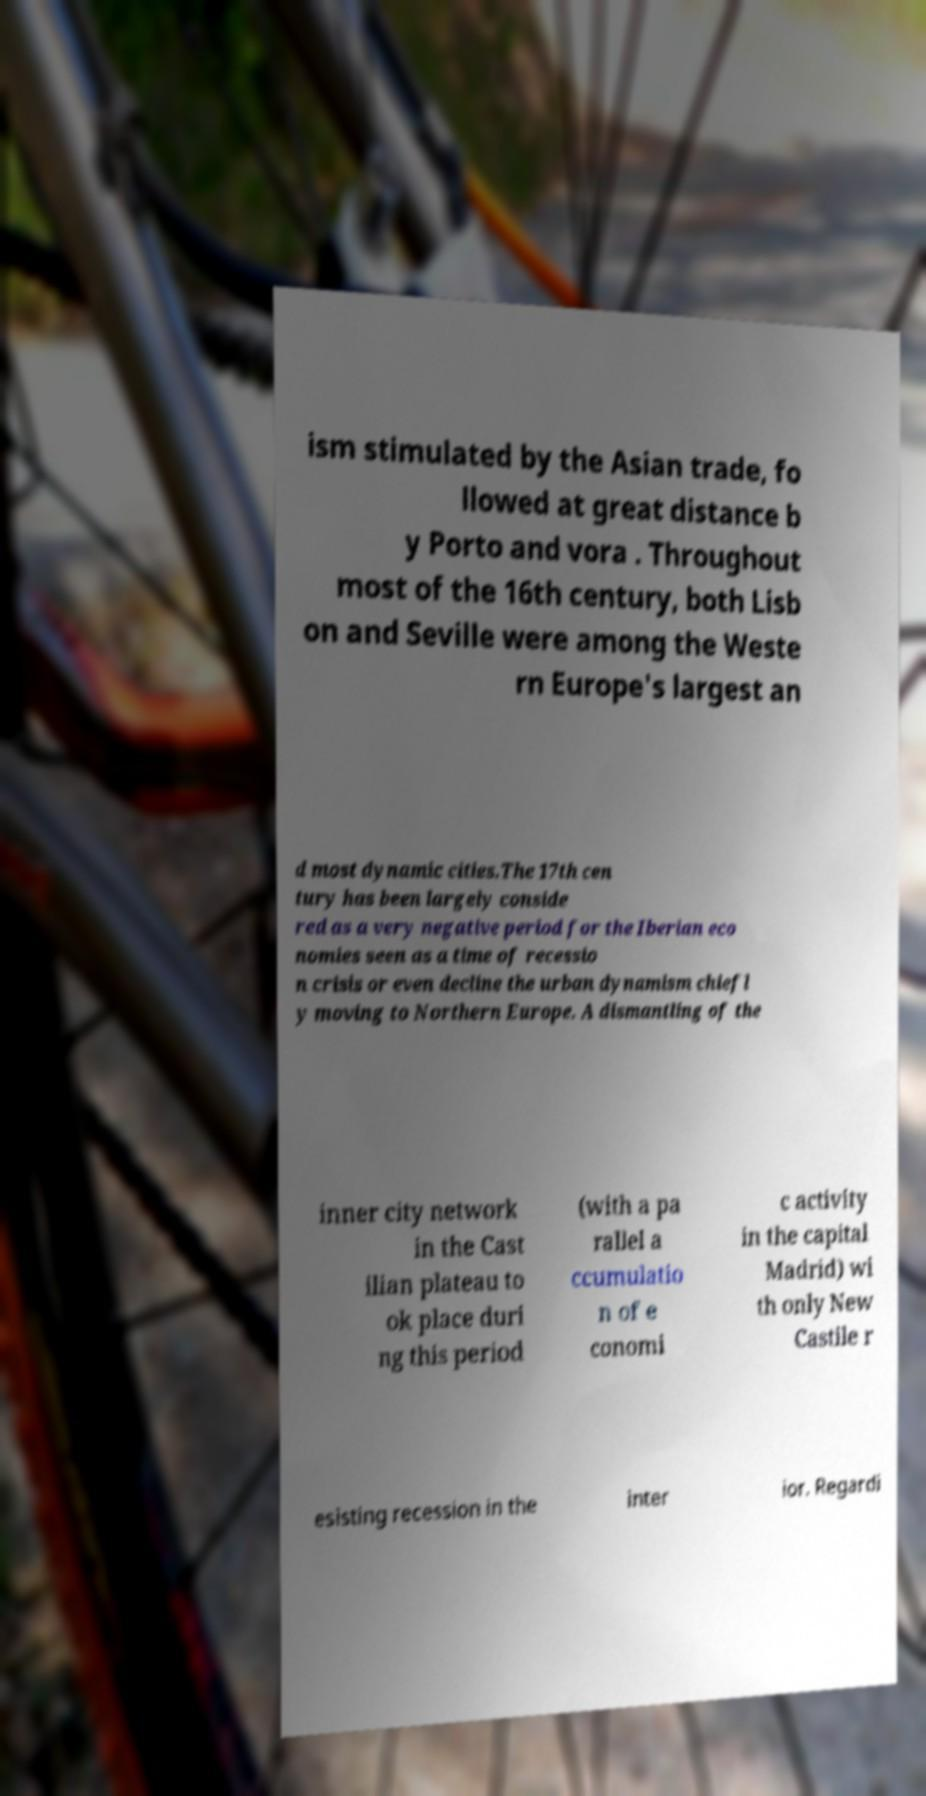What messages or text are displayed in this image? I need them in a readable, typed format. ism stimulated by the Asian trade, fo llowed at great distance b y Porto and vora . Throughout most of the 16th century, both Lisb on and Seville were among the Weste rn Europe's largest an d most dynamic cities.The 17th cen tury has been largely conside red as a very negative period for the Iberian eco nomies seen as a time of recessio n crisis or even decline the urban dynamism chiefl y moving to Northern Europe. A dismantling of the inner city network in the Cast ilian plateau to ok place duri ng this period (with a pa rallel a ccumulatio n of e conomi c activity in the capital Madrid) wi th only New Castile r esisting recession in the inter ior. Regardi 